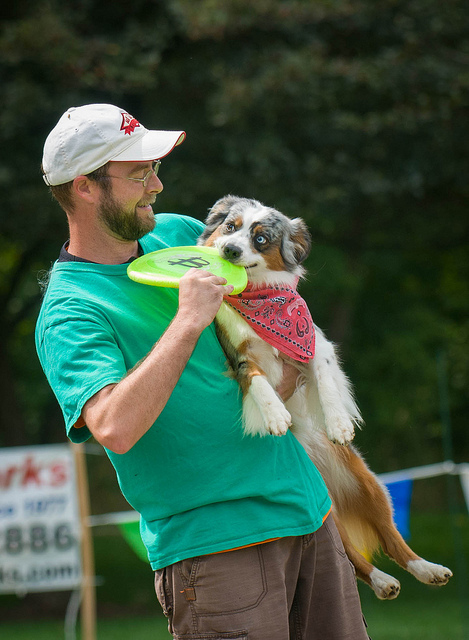Please transcribe the text information in this image. B ks 